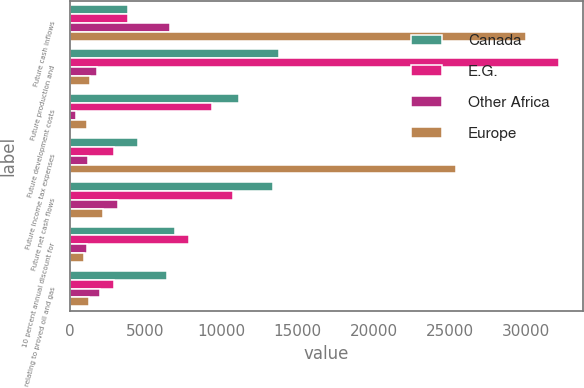<chart> <loc_0><loc_0><loc_500><loc_500><stacked_bar_chart><ecel><fcel>Future cash inflows<fcel>Future production and<fcel>Future development costs<fcel>Future income tax expenses<fcel>Future net cash flows<fcel>10 percent annual discount for<fcel>relating to proved oil and gas<nl><fcel>Canada<fcel>3822.5<fcel>13765<fcel>11104<fcel>4489<fcel>13352<fcel>6956<fcel>6396<nl><fcel>E.G.<fcel>3822.5<fcel>32131<fcel>9350<fcel>2948<fcel>10742<fcel>7842<fcel>2900<nl><fcel>Other Africa<fcel>6627<fcel>1829<fcel>451<fcel>1191<fcel>3156<fcel>1178<fcel>1978<nl><fcel>Europe<fcel>29993<fcel>1315<fcel>1119<fcel>25370<fcel>2189<fcel>939<fcel>1250<nl></chart> 